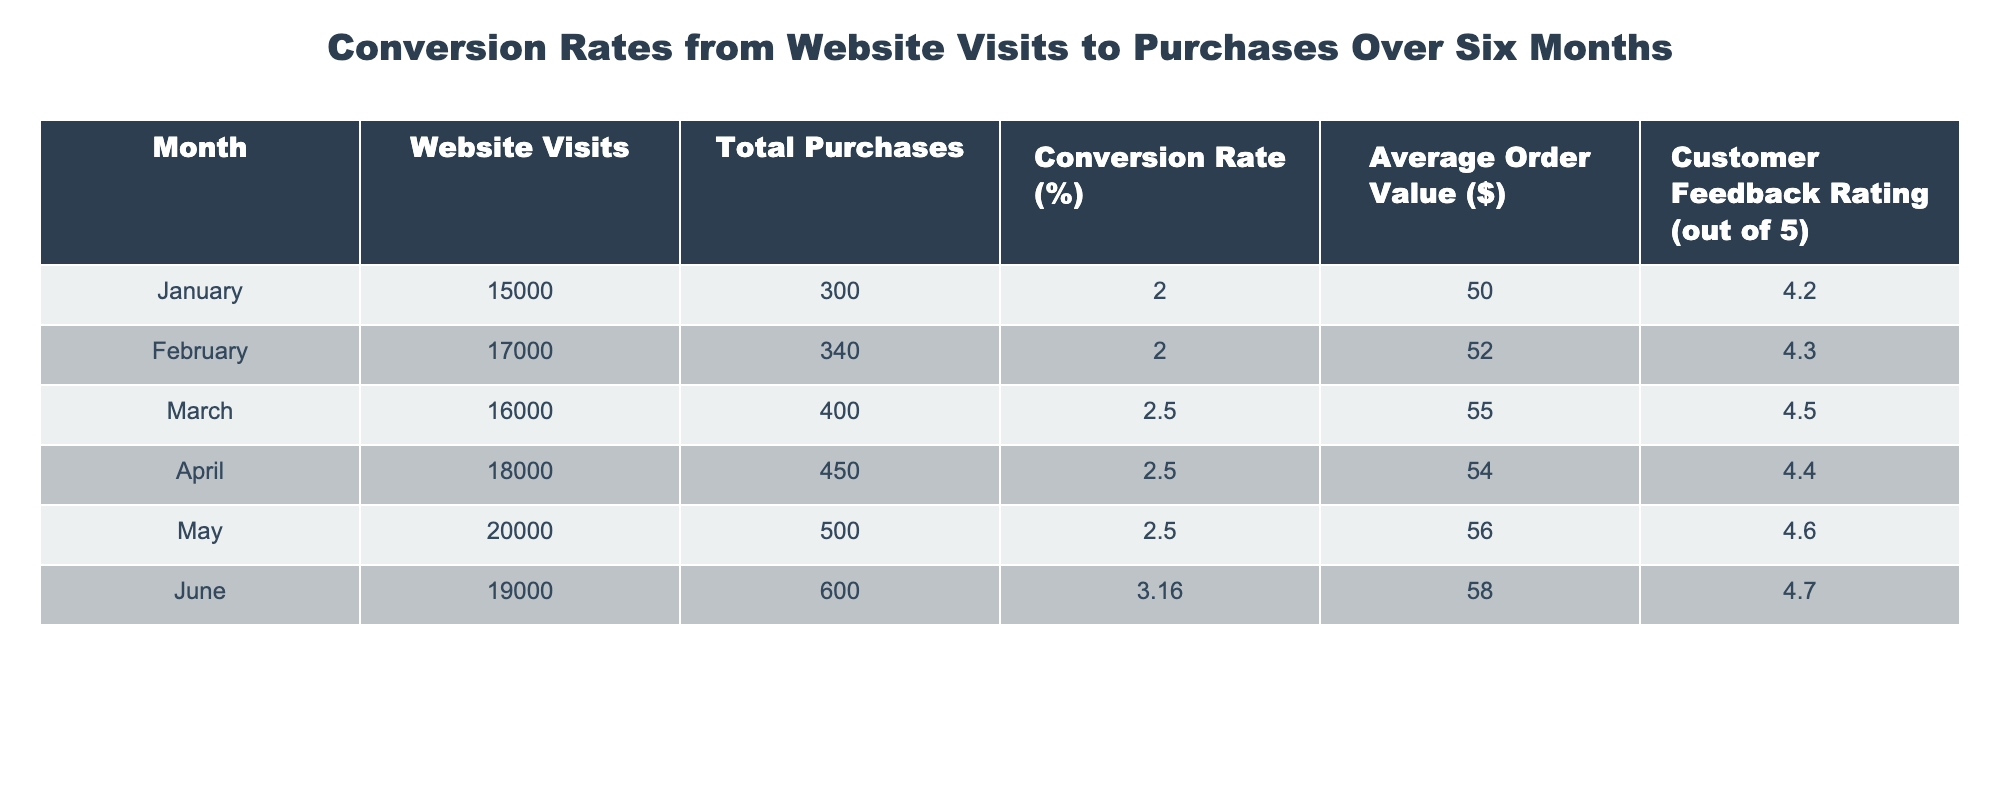What was the highest conversion rate recorded in the table? The highest conversion rate can be identified by looking at the "Conversion Rate (%)" column. The values listed are 2.00, 2.00, 2.50, 2.50, 2.50, and 3.16. The maximum value here is 3.16, which corresponds to June.
Answer: 3.16 In which month did the total purchases exceed 500? To determine the month when total purchases exceeded 500, look at the "Total Purchases" column. The values are 300, 340, 400, 450, 500, and 600. The first time the total exceeds 500 is in June, where total purchases are 600.
Answer: June What was the average order value in May? The average order value for May is found directly in the "Average Order Value ($)" column. The value for May is 56.00.
Answer: 56.00 How many website visits were recorded in April compared to February? In April, there were 18,000 website visits, and in February, there were 17,000 visits. The difference is calculated as 18,000 - 17,000 = 1,000. So, April had 1,000 more website visits than February.
Answer: 1,000 Did the customer feedback rating increase from January to June? By comparing the "Customer Feedback Rating" values from January (4.2) and June (4.7), it can be noted that June has a higher rating than January, hence the feedback rating did indeed increase.
Answer: Yes What is the total number of purchases over the six months? To find the total number of purchases, sum the values in the "Total Purchases" column: 300 + 340 + 400 + 450 + 500 + 600 = 2,590.
Answer: 2,590 Which month had the lowest customer feedback rating, and what was the rating? Inspecting the "Customer Feedback Rating" column: January (4.2), February (4.3), March (4.5), April (4.4), May (4.6), and June (4.7) shows that January has the lowest score of 4.2.
Answer: January, 4.2 How did the average order value change from March to June? The average order value increased from March (55.00) to June (58.00). To find the change, the values are subtracted: 58.00 - 55.00 = 3.00. This indicates an increase of 3.00 from March to June.
Answer: 3.00 What was the conversion rate for March? The conversion rate for March is specified in the "Conversion Rate (%)" column, which shows a value of 2.50.
Answer: 2.50 